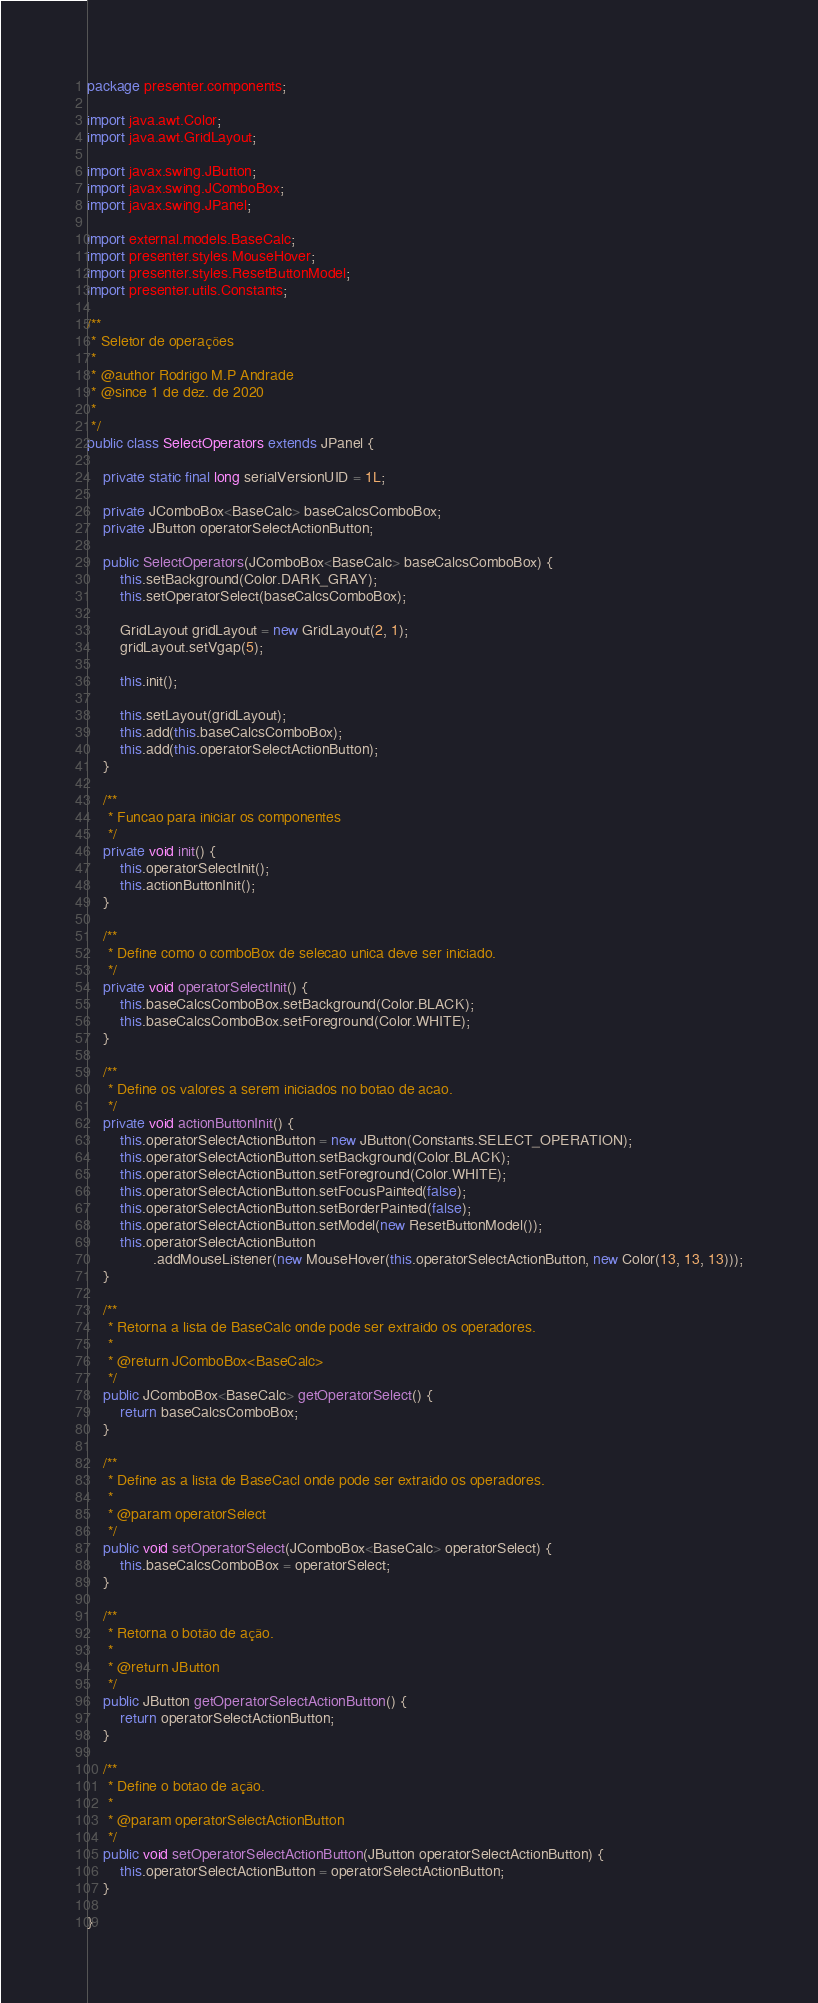<code> <loc_0><loc_0><loc_500><loc_500><_Java_>package presenter.components;

import java.awt.Color;
import java.awt.GridLayout;

import javax.swing.JButton;
import javax.swing.JComboBox;
import javax.swing.JPanel;

import external.models.BaseCalc;
import presenter.styles.MouseHover;
import presenter.styles.ResetButtonModel;
import presenter.utils.Constants;

/**
 * Seletor de operações
 * 
 * @author Rodrigo M.P Andrade
 * @since 1 de dez. de 2020
 *
 */
public class SelectOperators extends JPanel {

	private static final long serialVersionUID = 1L;

	private JComboBox<BaseCalc> baseCalcsComboBox;
	private JButton operatorSelectActionButton;

	public SelectOperators(JComboBox<BaseCalc> baseCalcsComboBox) {
		this.setBackground(Color.DARK_GRAY);
		this.setOperatorSelect(baseCalcsComboBox);

		GridLayout gridLayout = new GridLayout(2, 1);
		gridLayout.setVgap(5);

		this.init();

		this.setLayout(gridLayout);
		this.add(this.baseCalcsComboBox);
		this.add(this.operatorSelectActionButton);
	}

	/**
	 * Funcao para iniciar os componentes
	 */
	private void init() {
		this.operatorSelectInit();
		this.actionButtonInit();
	}

	/**
	 * Define como o comboBox de selecao unica deve ser iniciado.
	 */
	private void operatorSelectInit() {
		this.baseCalcsComboBox.setBackground(Color.BLACK);
		this.baseCalcsComboBox.setForeground(Color.WHITE);
	}

	/**
	 * Define os valores a serem iniciados no botao de acao.
	 */
	private void actionButtonInit() {
		this.operatorSelectActionButton = new JButton(Constants.SELECT_OPERATION);
		this.operatorSelectActionButton.setBackground(Color.BLACK);
		this.operatorSelectActionButton.setForeground(Color.WHITE);
		this.operatorSelectActionButton.setFocusPainted(false);
		this.operatorSelectActionButton.setBorderPainted(false);
		this.operatorSelectActionButton.setModel(new ResetButtonModel());
		this.operatorSelectActionButton
				.addMouseListener(new MouseHover(this.operatorSelectActionButton, new Color(13, 13, 13)));
	}

	/**
	 * Retorna a lista de BaseCalc onde pode ser extraido os operadores.
	 * 
	 * @return JComboBox<BaseCalc>
	 */
	public JComboBox<BaseCalc> getOperatorSelect() {
		return baseCalcsComboBox;
	}

	/**
	 * Define as a lista de BaseCacl onde pode ser extraido os operadores.
	 * 
	 * @param operatorSelect
	 */
	public void setOperatorSelect(JComboBox<BaseCalc> operatorSelect) {
		this.baseCalcsComboBox = operatorSelect;
	}

	/**
	 * Retorna o botão de ação.
	 * 
	 * @return JButton
	 */
	public JButton getOperatorSelectActionButton() {
		return operatorSelectActionButton;
	}

	/**
	 * Define o botao de ação.
	 * 
	 * @param operatorSelectActionButton
	 */
	public void setOperatorSelectActionButton(JButton operatorSelectActionButton) {
		this.operatorSelectActionButton = operatorSelectActionButton;
	}

}
</code> 